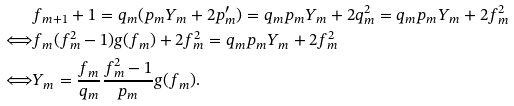Convert formula to latex. <formula><loc_0><loc_0><loc_500><loc_500>& f _ { m + 1 } + 1 = q _ { m } ( p _ { m } Y _ { m } + 2 p _ { m } ^ { \prime } ) = q _ { m } p _ { m } Y _ { m } + 2 q _ { m } ^ { 2 } = q _ { m } p _ { m } Y _ { m } + 2 f _ { m } ^ { 2 } \\ \Longleftrightarrow & f _ { m } ( f _ { m } ^ { 2 } - 1 ) g ( f _ { m } ) + 2 f _ { m } ^ { 2 } = q _ { m } p _ { m } Y _ { m } + 2 f _ { m } ^ { 2 } \\ \Longleftrightarrow & Y _ { m } = \frac { f _ { m } } { q _ { m } } \frac { f _ { m } ^ { 2 } - 1 } { p _ { m } } g ( f _ { m } ) .</formula> 